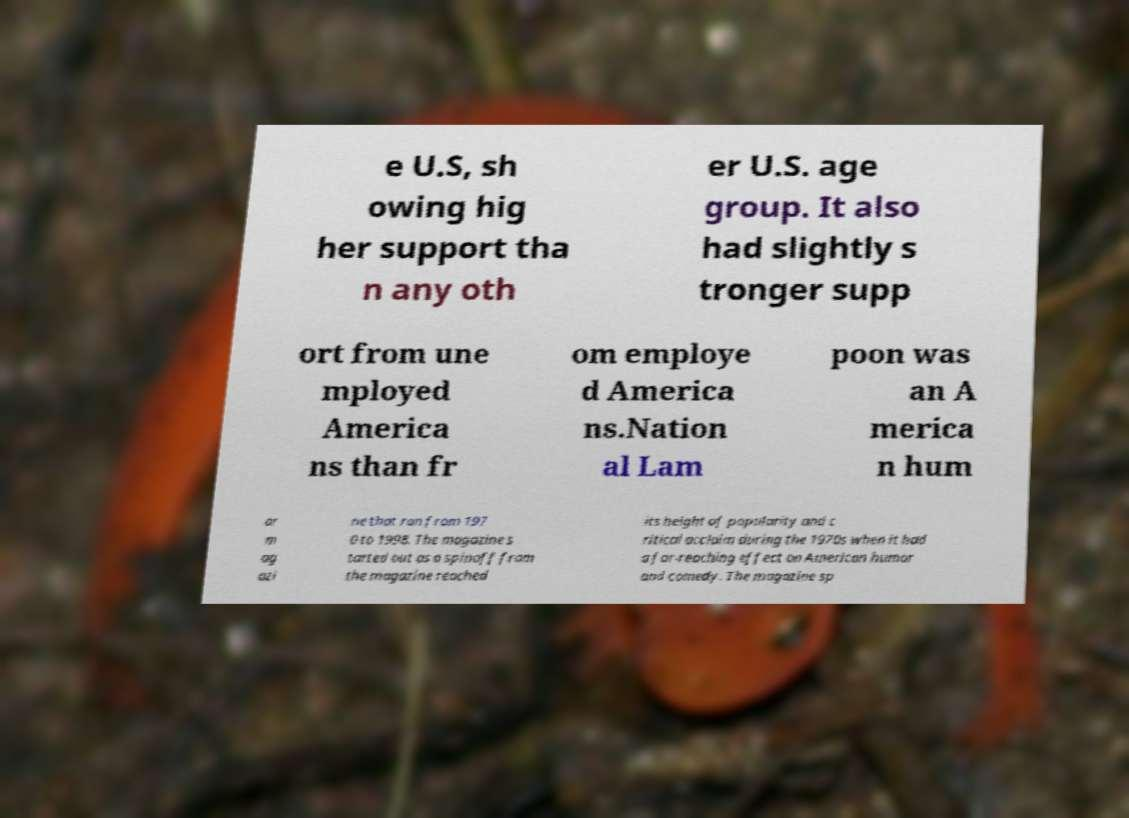Please read and relay the text visible in this image. What does it say? e U.S, sh owing hig her support tha n any oth er U.S. age group. It also had slightly s tronger supp ort from une mployed America ns than fr om employe d America ns.Nation al Lam poon was an A merica n hum or m ag azi ne that ran from 197 0 to 1998. The magazine s tarted out as a spinoff from the magazine reached its height of popularity and c ritical acclaim during the 1970s when it had a far-reaching effect on American humor and comedy. The magazine sp 